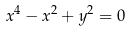Convert formula to latex. <formula><loc_0><loc_0><loc_500><loc_500>x ^ { 4 } - x ^ { 2 } + y ^ { 2 } = 0</formula> 